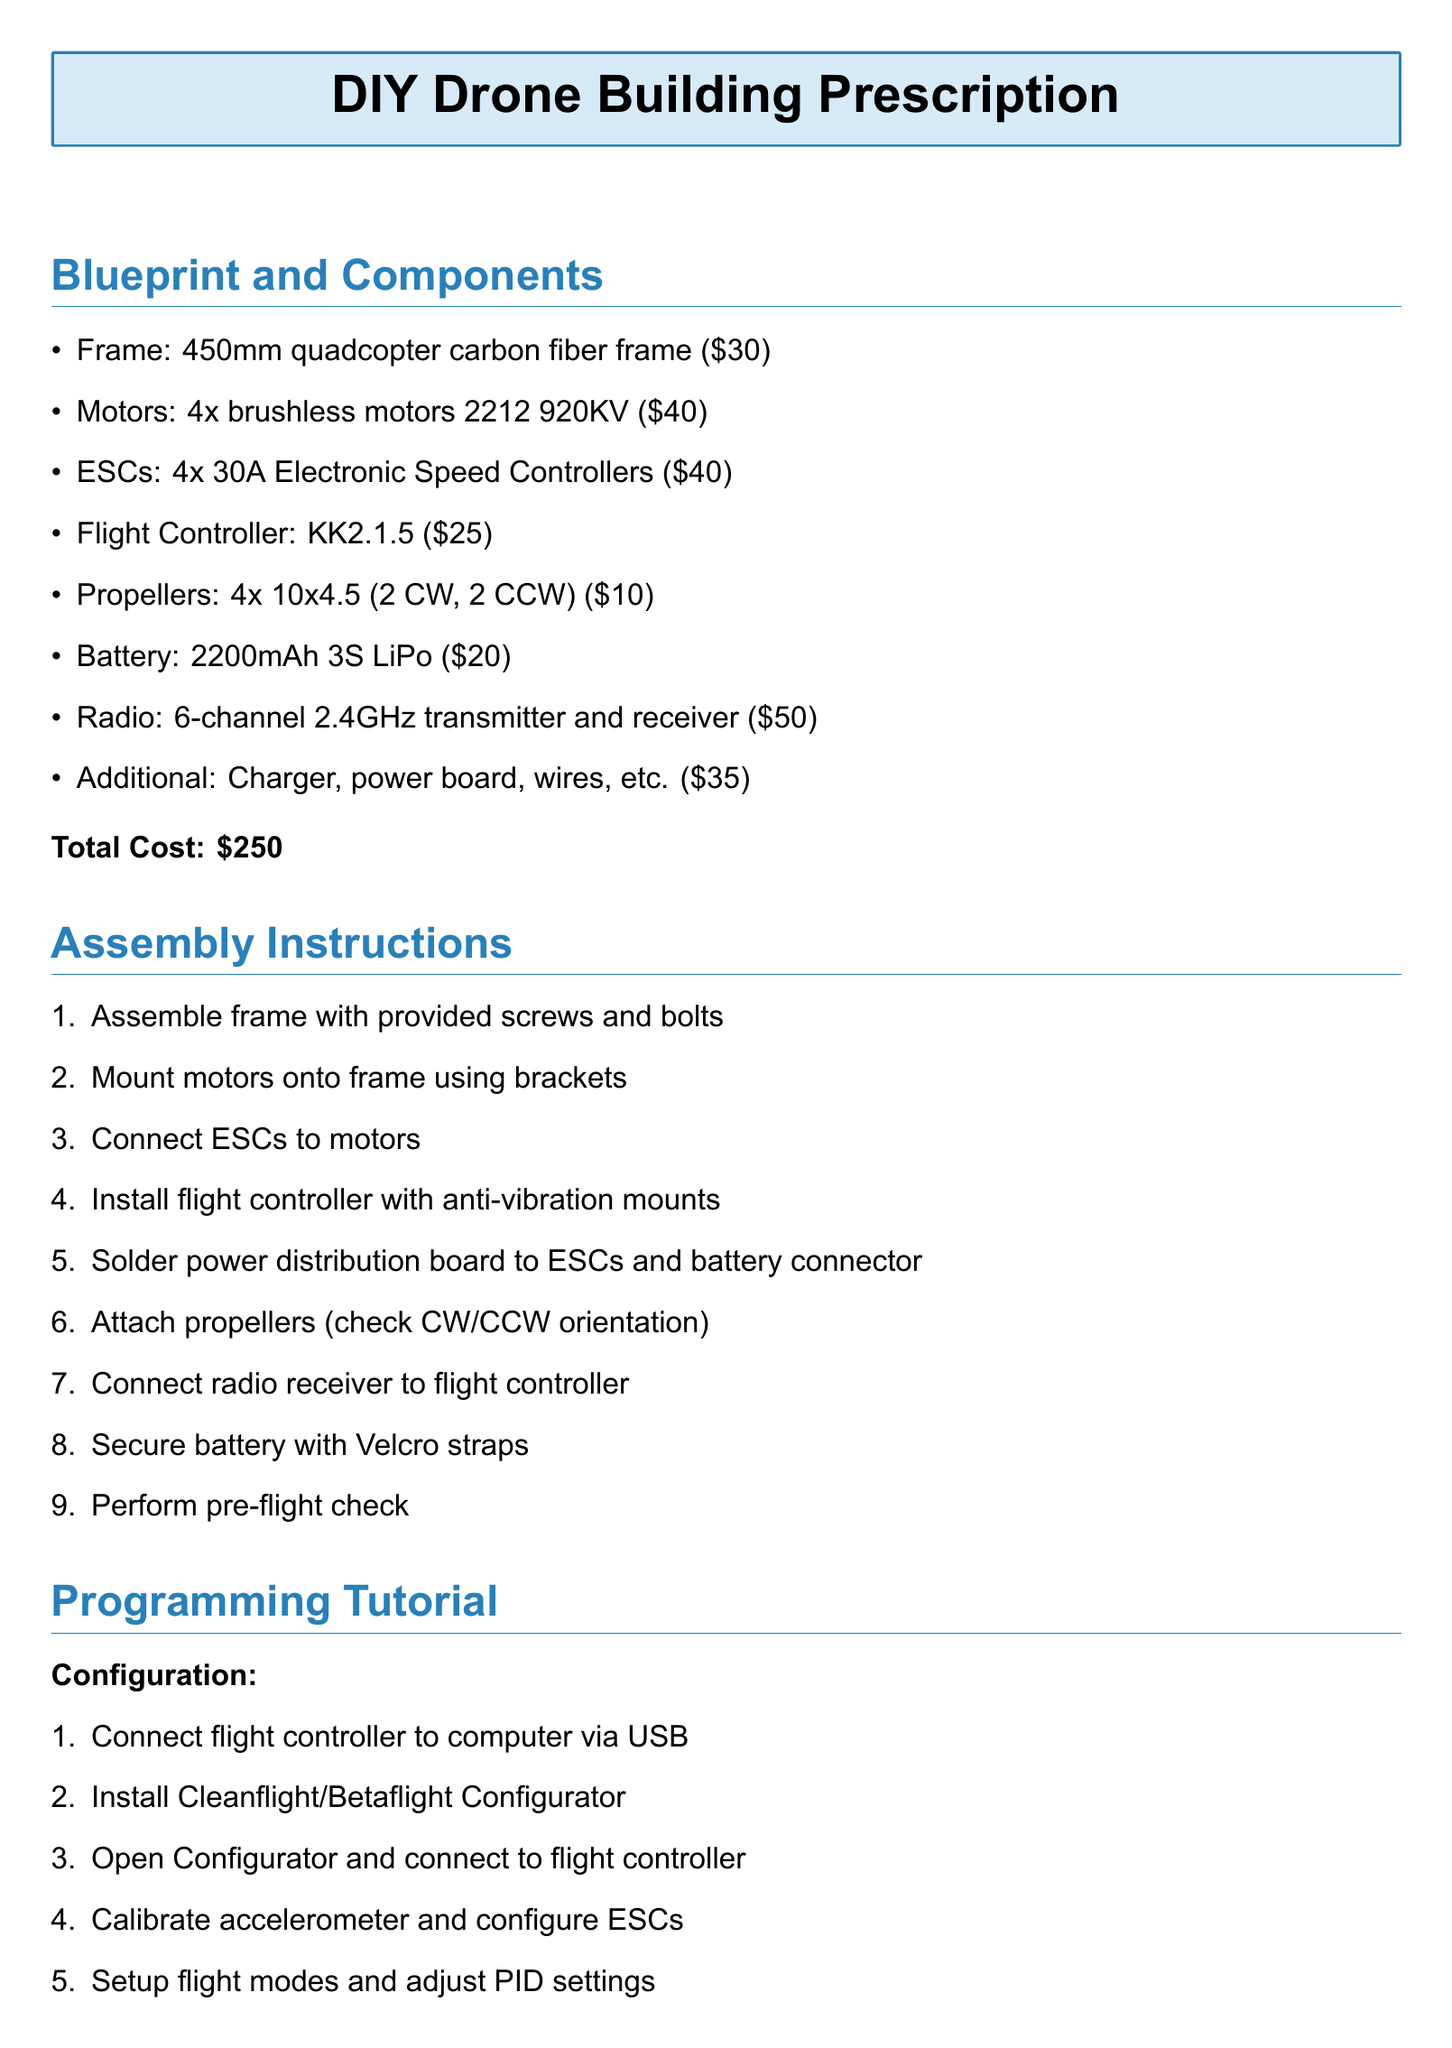What is the total cost of building the DIY drone? The total cost is listed at the end of the components section in the document.
Answer: $250 How many brushless motors are included? The number of brushless motors is specified in the components list.
Answer: 4 What is the size of the carbon fiber frame? The dimensions of the frame are provided in the first bullet point of the blueprint section.
Answer: 450mm What flight controller model is recommended? The model of the flight controller is explicitly mentioned in the document under components.
Answer: KK2.1.5 What needs to be connected to the flight controller for programming? The document mentions connecting this component to the flight controller for programming in the tutorial section.
Answer: Computer Which software is recommended for configuration? The recommended software for configuration is provided in the programming tutorial section.
Answer: Cleanflight/Betaflight Configurator How many steps are in the assembly instructions? The total number of steps is indicated by the enumeration in the assembly instructions section.
Answer: 9 What is the first step in assembly instructions? The first step is stated clearly in the list of assembly instructions.
Answer: Assemble frame What is one necessary component for flight control programming? The necessary component for programming is detailed in the basic flight control programming part of the document.
Answer: MultiWii library 